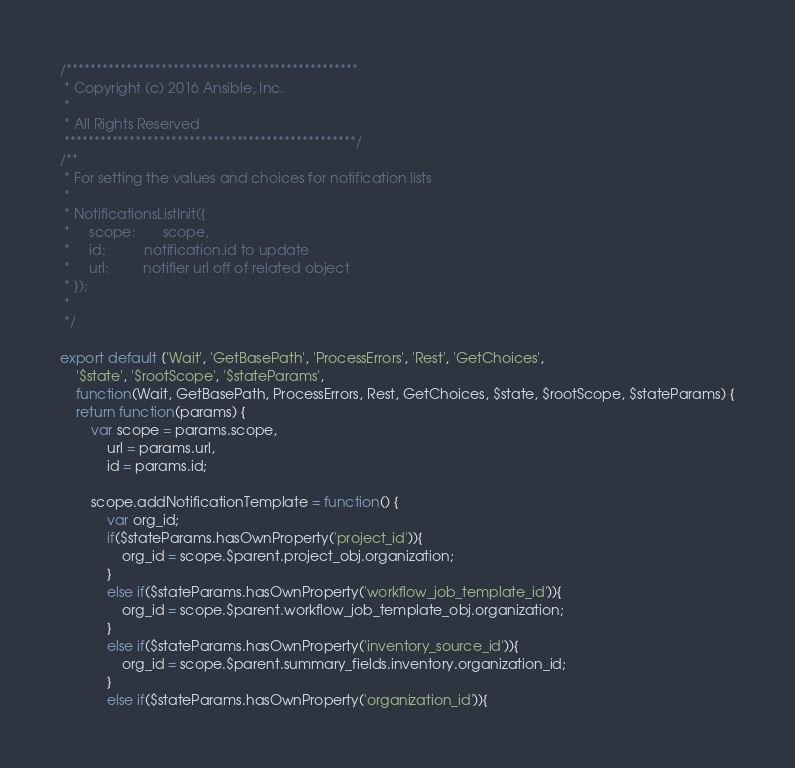<code> <loc_0><loc_0><loc_500><loc_500><_JavaScript_>/*************************************************
 * Copyright (c) 2016 Ansible, Inc.
 *
 * All Rights Reserved
 *************************************************/
/**
 * For setting the values and choices for notification lists
 *
 * NotificationsListInit({
 *     scope:       scope,
 *     id:          notification.id to update
 *     url:         notifier url off of related object
 * });
 *
 */

export default ['Wait', 'GetBasePath', 'ProcessErrors', 'Rest', 'GetChoices',
    '$state', '$rootScope', '$stateParams',
    function(Wait, GetBasePath, ProcessErrors, Rest, GetChoices, $state, $rootScope, $stateParams) {
    return function(params) {
        var scope = params.scope,
            url = params.url,
            id = params.id;

        scope.addNotificationTemplate = function() {
            var org_id;
            if($stateParams.hasOwnProperty('project_id')){
                org_id = scope.$parent.project_obj.organization;
            }
            else if($stateParams.hasOwnProperty('workflow_job_template_id')){
                org_id = scope.$parent.workflow_job_template_obj.organization;
            }
            else if($stateParams.hasOwnProperty('inventory_source_id')){
                org_id = scope.$parent.summary_fields.inventory.organization_id;
            }
            else if($stateParams.hasOwnProperty('organization_id')){</code> 